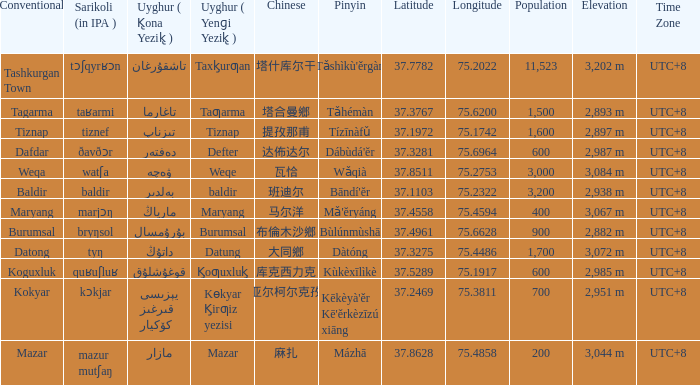Name the pinyin for تىزناپ Tízīnàfǔ. 